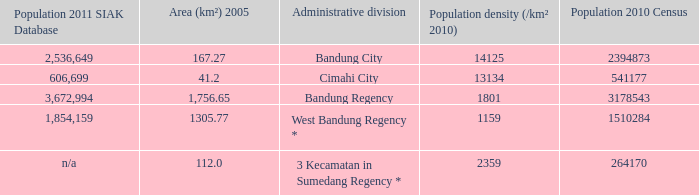Which administrative division had a 2011 population of 606,699 according to the siak database? Cimahi City. 